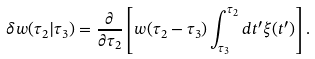Convert formula to latex. <formula><loc_0><loc_0><loc_500><loc_500>\delta w ( \tau _ { 2 } | \tau _ { 3 } ) = \frac { \partial } { \partial \tau _ { 2 } } \left [ w ( \tau _ { 2 } - \tau _ { 3 } ) \int _ { \tau _ { 3 } } ^ { \tau _ { 2 } } d t ^ { \prime } \xi ( t ^ { \prime } ) \right ] .</formula> 